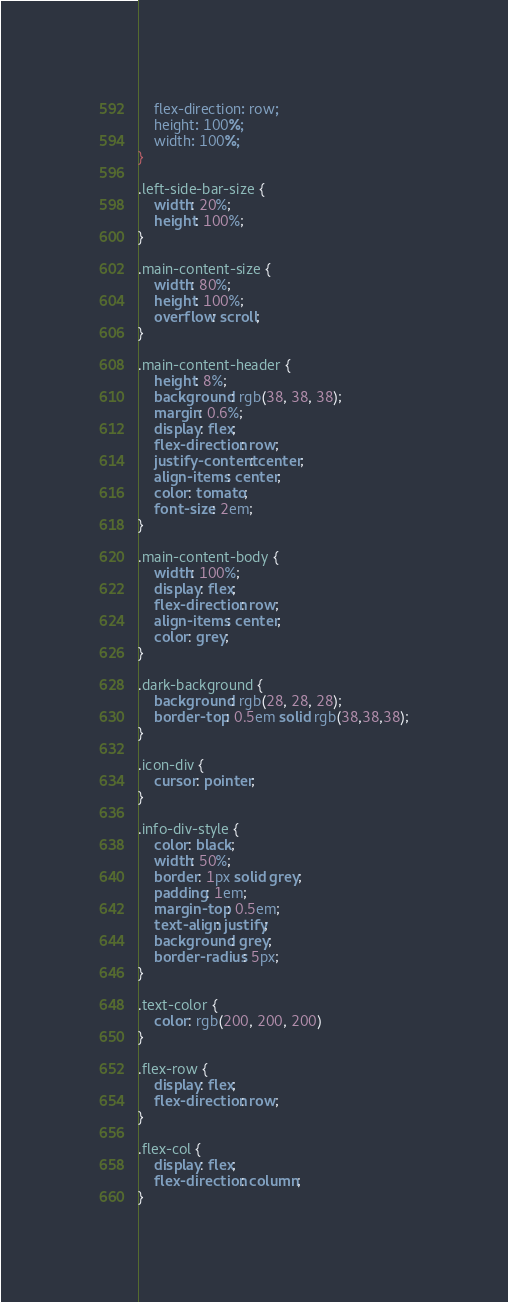Convert code to text. <code><loc_0><loc_0><loc_500><loc_500><_CSS_>    flex-direction: row;
    height: 100%;
    width: 100%;
}

.left-side-bar-size {
    width: 20%;
    height: 100%;
}

.main-content-size {
    width: 80%;
    height: 100%;
    overflow: scroll;
}

.main-content-header {
    height: 8%;
    background: rgb(38, 38, 38);
    margin: 0.6%;
    display: flex;
    flex-direction: row;
    justify-content: center;
    align-items: center;
    color: tomato;
    font-size: 2em;
}

.main-content-body {
    width: 100%;
    display: flex;
    flex-direction: row;
    align-items: center;
    color: grey;
}

.dark-background {
    background: rgb(28, 28, 28);
    border-top: 0.5em solid rgb(38,38,38);
}

.icon-div {
    cursor: pointer;
}

.info-div-style {
    color: black;
    width: 50%;
    border: 1px solid grey;
    padding: 1em;
    margin-top: 0.5em;
    text-align: justify;
    background: grey;
    border-radius: 5px;
}

.text-color {
    color: rgb(200, 200, 200)
}

.flex-row {
    display: flex;
    flex-direction: row;
}

.flex-col {
    display: flex;
    flex-direction: column;
}</code> 